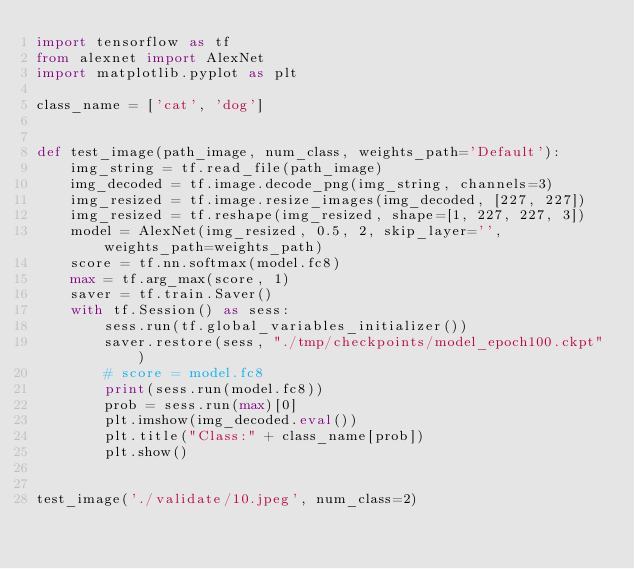Convert code to text. <code><loc_0><loc_0><loc_500><loc_500><_Python_>import tensorflow as tf
from alexnet import AlexNet
import matplotlib.pyplot as plt

class_name = ['cat', 'dog']


def test_image(path_image, num_class, weights_path='Default'):
    img_string = tf.read_file(path_image)
    img_decoded = tf.image.decode_png(img_string, channels=3)
    img_resized = tf.image.resize_images(img_decoded, [227, 227])
    img_resized = tf.reshape(img_resized, shape=[1, 227, 227, 3])
    model = AlexNet(img_resized, 0.5, 2, skip_layer='', weights_path=weights_path)
    score = tf.nn.softmax(model.fc8)
    max = tf.arg_max(score, 1)
    saver = tf.train.Saver()
    with tf.Session() as sess:
        sess.run(tf.global_variables_initializer())
        saver.restore(sess, "./tmp/checkpoints/model_epoch100.ckpt")
        # score = model.fc8
        print(sess.run(model.fc8))
        prob = sess.run(max)[0]
        plt.imshow(img_decoded.eval())
        plt.title("Class:" + class_name[prob])
        plt.show()


test_image('./validate/10.jpeg', num_class=2)
</code> 